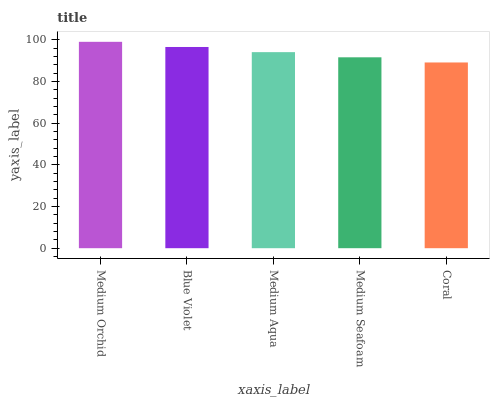Is Coral the minimum?
Answer yes or no. Yes. Is Medium Orchid the maximum?
Answer yes or no. Yes. Is Blue Violet the minimum?
Answer yes or no. No. Is Blue Violet the maximum?
Answer yes or no. No. Is Medium Orchid greater than Blue Violet?
Answer yes or no. Yes. Is Blue Violet less than Medium Orchid?
Answer yes or no. Yes. Is Blue Violet greater than Medium Orchid?
Answer yes or no. No. Is Medium Orchid less than Blue Violet?
Answer yes or no. No. Is Medium Aqua the high median?
Answer yes or no. Yes. Is Medium Aqua the low median?
Answer yes or no. Yes. Is Medium Orchid the high median?
Answer yes or no. No. Is Blue Violet the low median?
Answer yes or no. No. 